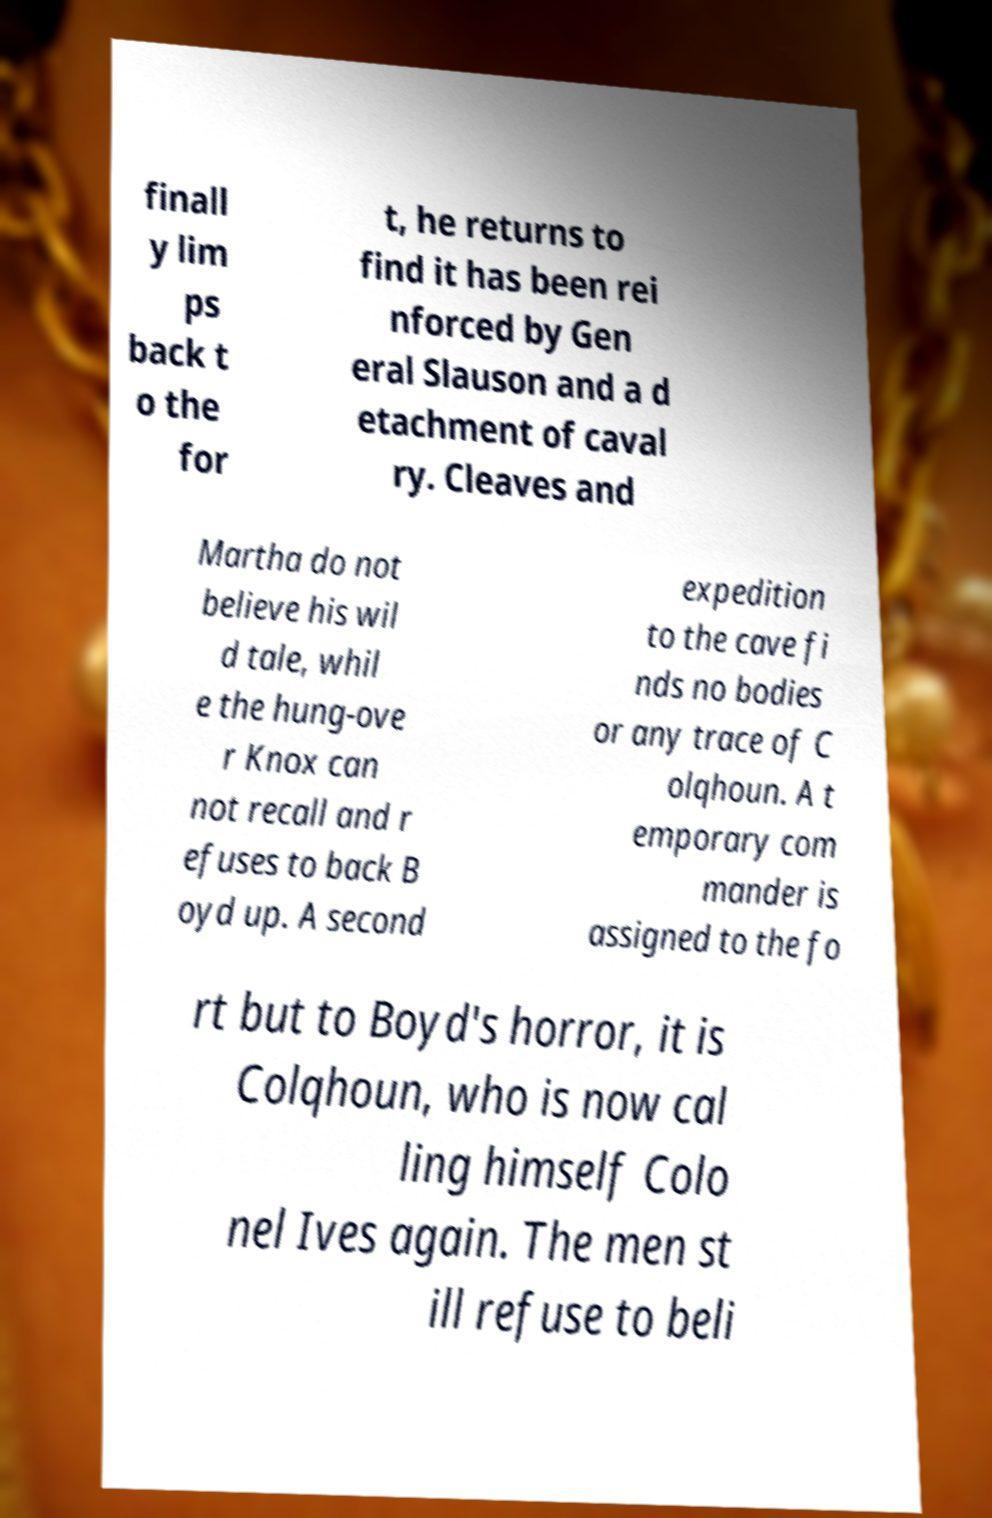Could you extract and type out the text from this image? finall y lim ps back t o the for t, he returns to find it has been rei nforced by Gen eral Slauson and a d etachment of caval ry. Cleaves and Martha do not believe his wil d tale, whil e the hung-ove r Knox can not recall and r efuses to back B oyd up. A second expedition to the cave fi nds no bodies or any trace of C olqhoun. A t emporary com mander is assigned to the fo rt but to Boyd's horror, it is Colqhoun, who is now cal ling himself Colo nel Ives again. The men st ill refuse to beli 